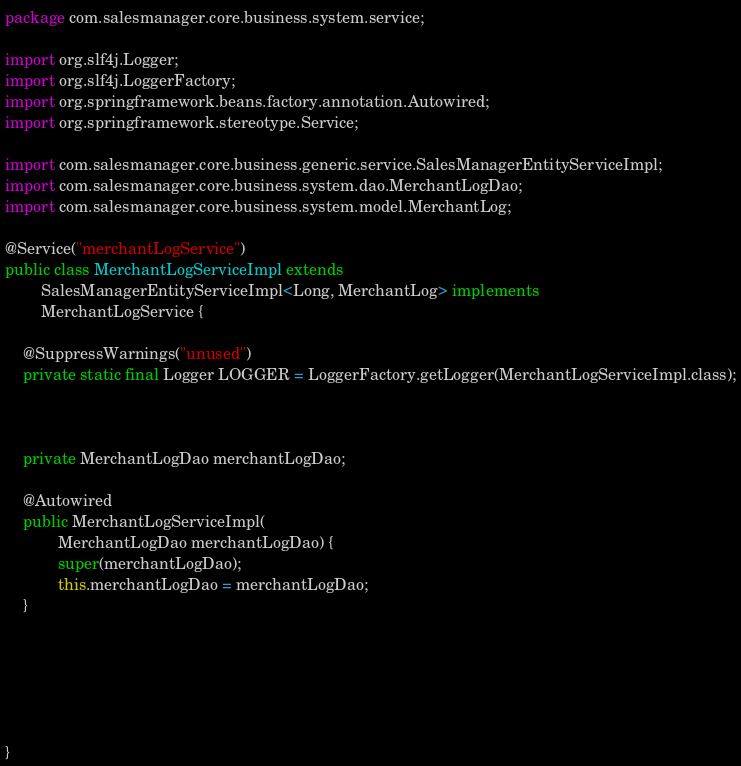Convert code to text. <code><loc_0><loc_0><loc_500><loc_500><_Java_>package com.salesmanager.core.business.system.service;

import org.slf4j.Logger;
import org.slf4j.LoggerFactory;
import org.springframework.beans.factory.annotation.Autowired;
import org.springframework.stereotype.Service;

import com.salesmanager.core.business.generic.service.SalesManagerEntityServiceImpl;
import com.salesmanager.core.business.system.dao.MerchantLogDao;
import com.salesmanager.core.business.system.model.MerchantLog;

@Service("merchantLogService")
public class MerchantLogServiceImpl extends
		SalesManagerEntityServiceImpl<Long, MerchantLog> implements
		MerchantLogService {
	
	@SuppressWarnings("unused")
	private static final Logger LOGGER = LoggerFactory.getLogger(MerchantLogServiceImpl.class);


	
	private MerchantLogDao merchantLogDao;
	
	@Autowired
	public MerchantLogServiceImpl(
			MerchantLogDao merchantLogDao) {
			super(merchantLogDao);
			this.merchantLogDao = merchantLogDao;
	}






}
</code> 